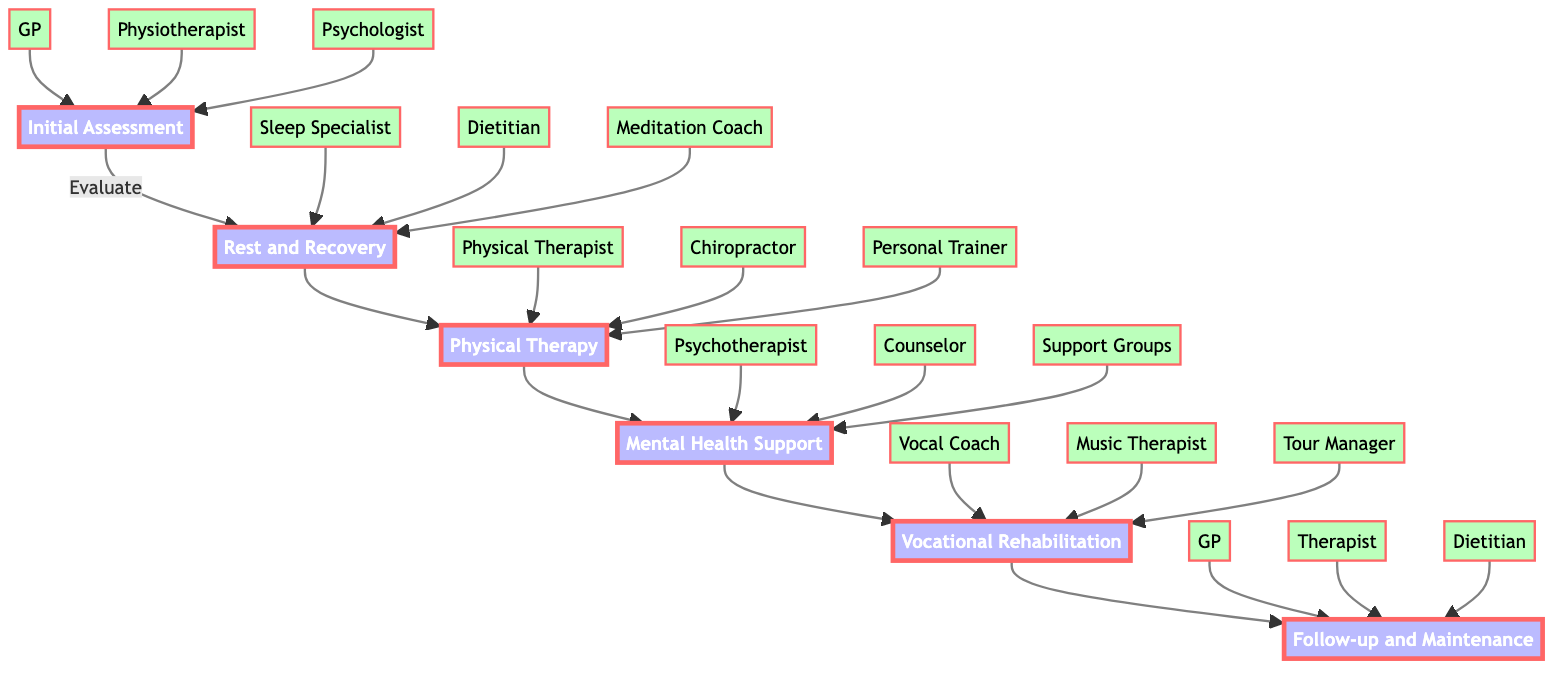What is the first step in the rehabilitation pathway? The first step is identified as "Initial Assessment" in the diagram. It is the entry point into the pathway for musicians recovering from fatigue and stress.
Answer: Initial Assessment How many total steps are in the rehabilitation pathway? By counting the distinct steps labeled in the diagram, we identify there are six major steps in the pathway, from "Initial Assessment" to "Follow-up and Maintenance."
Answer: Six What is the last step of the pathway? The final step is "Follow-up and Maintenance," which is positioned at the end of the flowchart.
Answer: Follow-up and Maintenance Which professional is associated with "Mental Health Support"? The diagram indicates that "Psychotherapist," "Counselor," and "Peer Support Groups" are the entities involved under the "Mental Health Support" step.
Answer: Psychotherapist What type of activity is included in "Rest and Recovery"? The activities listed under "Rest and Recovery" include "Sleep therapy," "Nutritional support," and "Guided meditation sessions." Notably, "Sleep therapy" is one significant activity mentioned.
Answer: Sleep therapy Which step comes before "Vocational Rehabilitation"? The pathway indicates that "Mental Health Support" is directly preceding "Vocational Rehabilitation," establishing a sequential flow from one to the next.
Answer: Mental Health Support How many entities are involved in the "Physical Therapy" step? Three distinct entities are linked to the "Physical Therapy" step: "Physical Therapist," "Chiropractor," and "Personal Trainer," which indicates the supportive roles in this therapeutic area.
Answer: Three What is the purpose of the "Initial Assessment"? The purpose of the "Initial Assessment" is described as a comprehensive evaluation performed by professionals knowledgeable about the music industry, which includes a review of medical history and mental health.
Answer: Comprehensive evaluation Which entity provides nutritional support during recovery? The "Dietitian" is the specific entity associated with providing nutritional support, as depicted in the "Rest and Recovery" section of the diagram.
Answer: Dietitian 